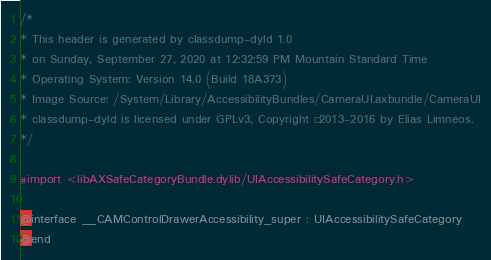<code> <loc_0><loc_0><loc_500><loc_500><_C_>/*
* This header is generated by classdump-dyld 1.0
* on Sunday, September 27, 2020 at 12:32:59 PM Mountain Standard Time
* Operating System: Version 14.0 (Build 18A373)
* Image Source: /System/Library/AccessibilityBundles/CameraUI.axbundle/CameraUI
* classdump-dyld is licensed under GPLv3, Copyright © 2013-2016 by Elias Limneos.
*/

#import <libAXSafeCategoryBundle.dylib/UIAccessibilitySafeCategory.h>

@interface __CAMControlDrawerAccessibility_super : UIAccessibilitySafeCategory
@end

</code> 